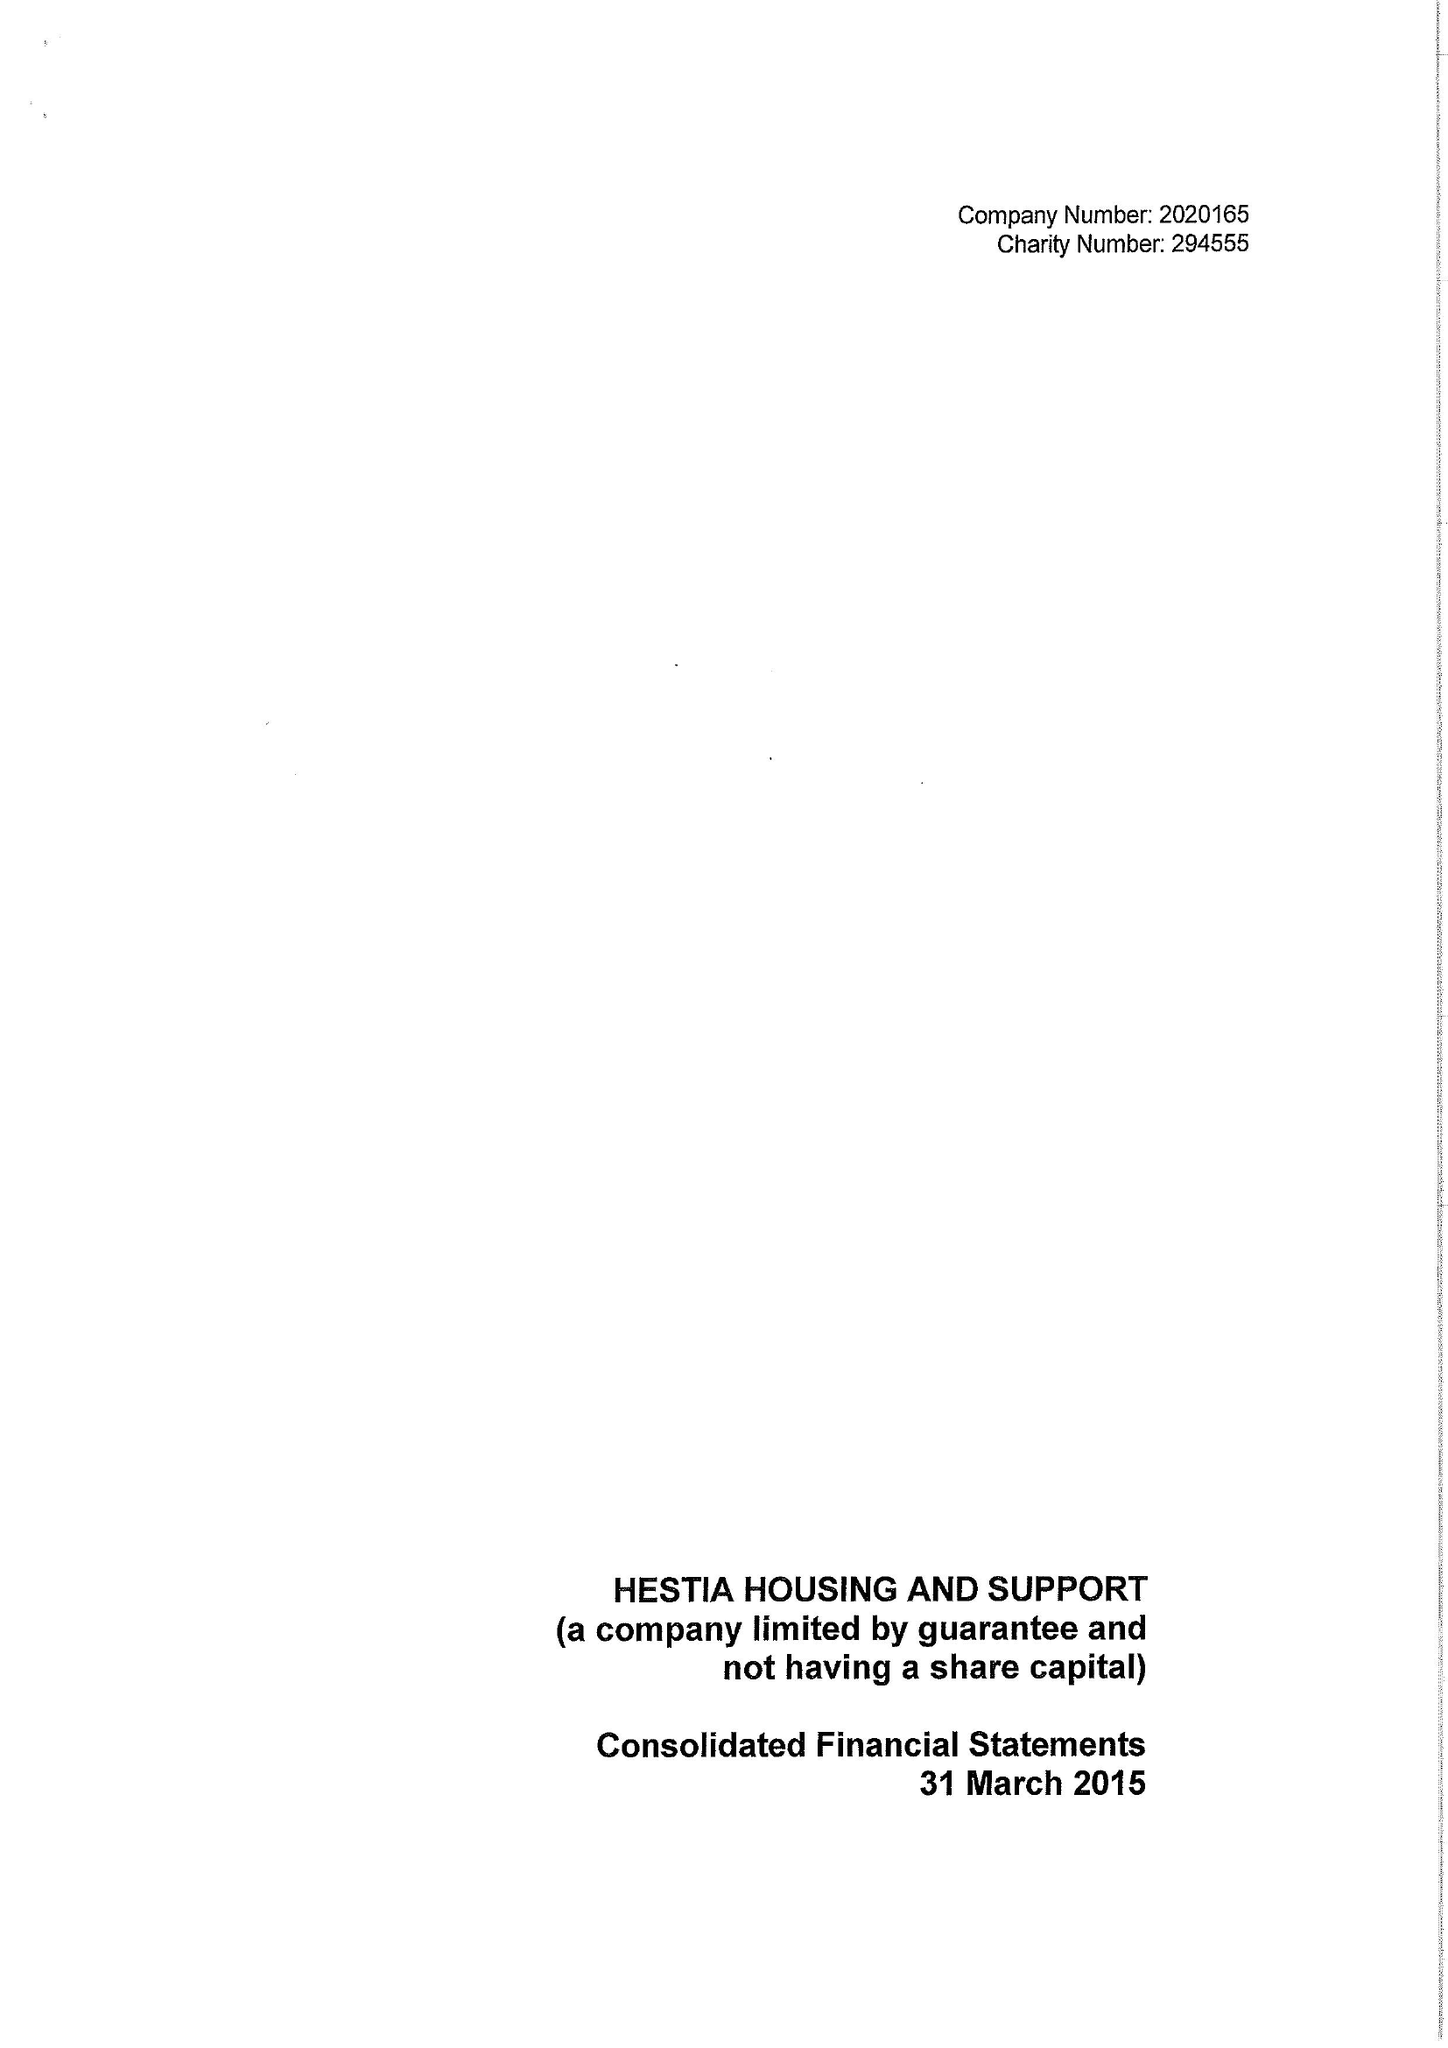What is the value for the charity_number?
Answer the question using a single word or phrase. 294555 